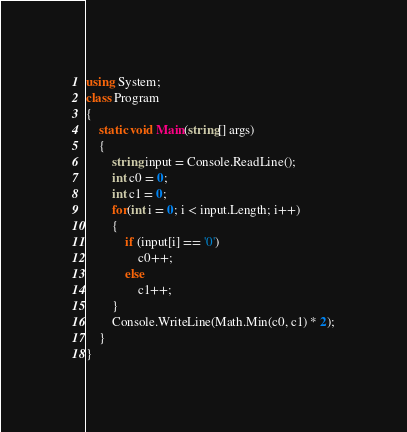<code> <loc_0><loc_0><loc_500><loc_500><_C#_>using System;
class Program
{
    static void Main(string[] args)
    {
        string input = Console.ReadLine();
        int c0 = 0;
        int c1 = 0;
        for(int i = 0; i < input.Length; i++)
        {
            if (input[i] == '0')
                c0++;
            else
                c1++;
        }
        Console.WriteLine(Math.Min(c0, c1) * 2);
    }
}
</code> 